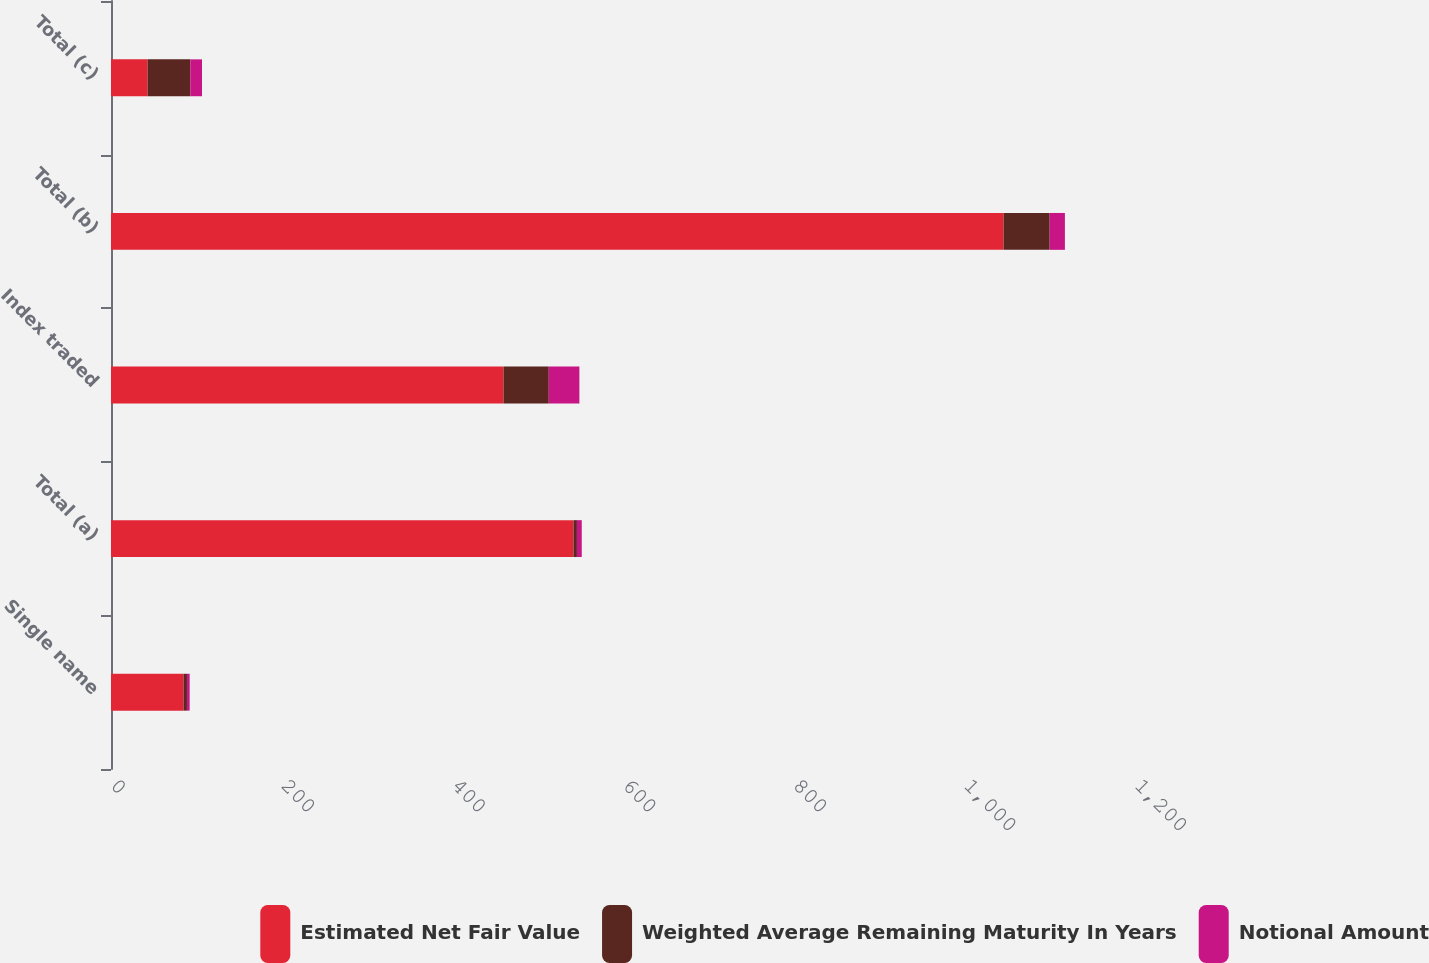Convert chart to OTSL. <chart><loc_0><loc_0><loc_500><loc_500><stacked_bar_chart><ecel><fcel>Single name<fcel>Total (a)<fcel>Index traded<fcel>Total (b)<fcel>Total (c)<nl><fcel>Estimated Net Fair Value<fcel>85<fcel>542<fcel>460<fcel>1046<fcel>42.945<nl><fcel>Weighted Average Remaining Maturity In Years<fcel>4<fcel>4<fcel>53<fcel>54<fcel>50<nl><fcel>Notional Amount<fcel>3.18<fcel>5.66<fcel>35.89<fcel>17.85<fcel>13.69<nl></chart> 